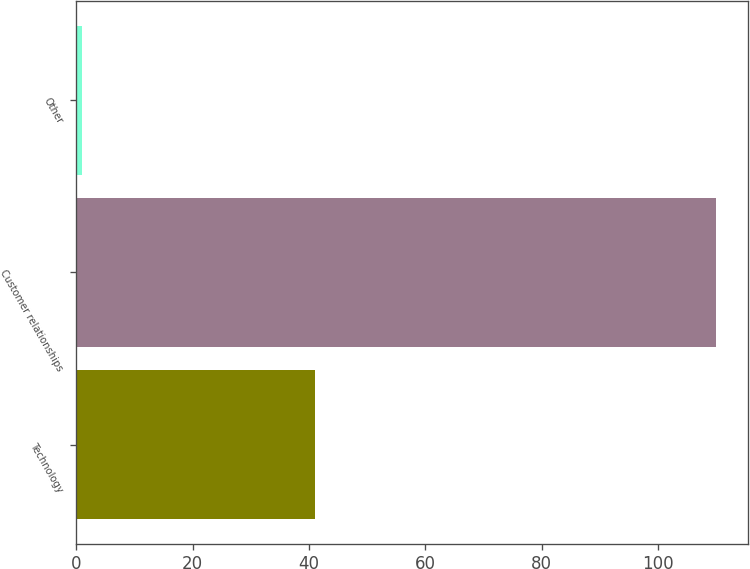Convert chart. <chart><loc_0><loc_0><loc_500><loc_500><bar_chart><fcel>Technology<fcel>Customer relationships<fcel>Other<nl><fcel>41<fcel>110<fcel>1<nl></chart> 